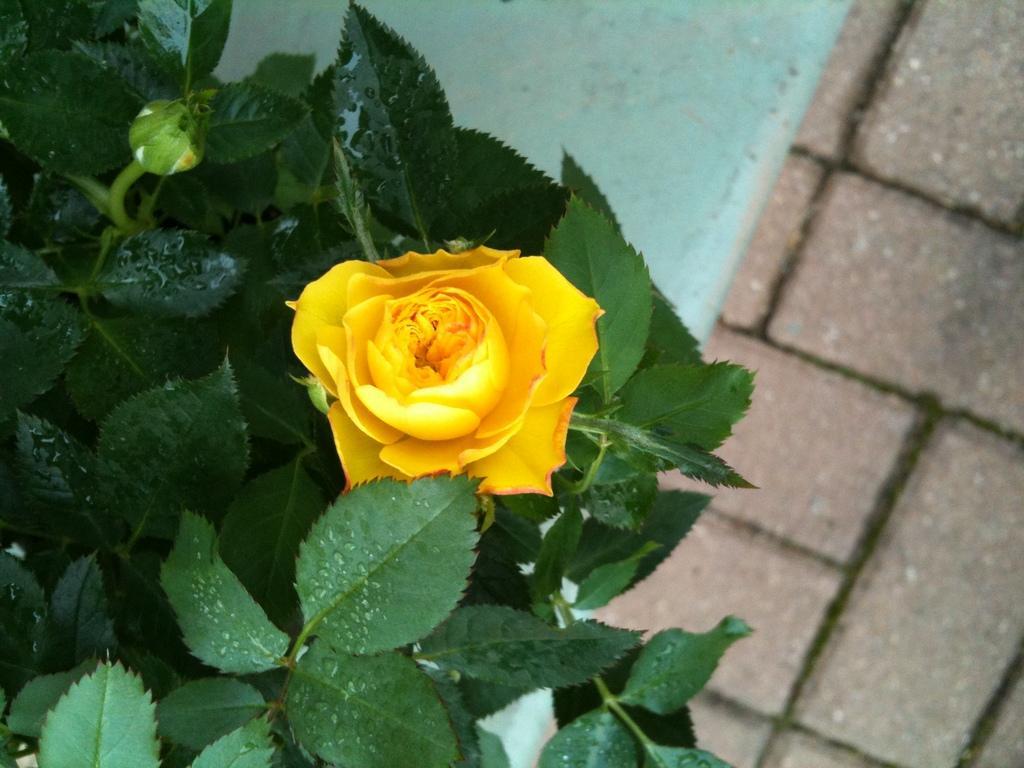Describe this image in one or two sentences. In this picture I can see a plant with a yellow flower and a bud, and in the background there is a pathway. 